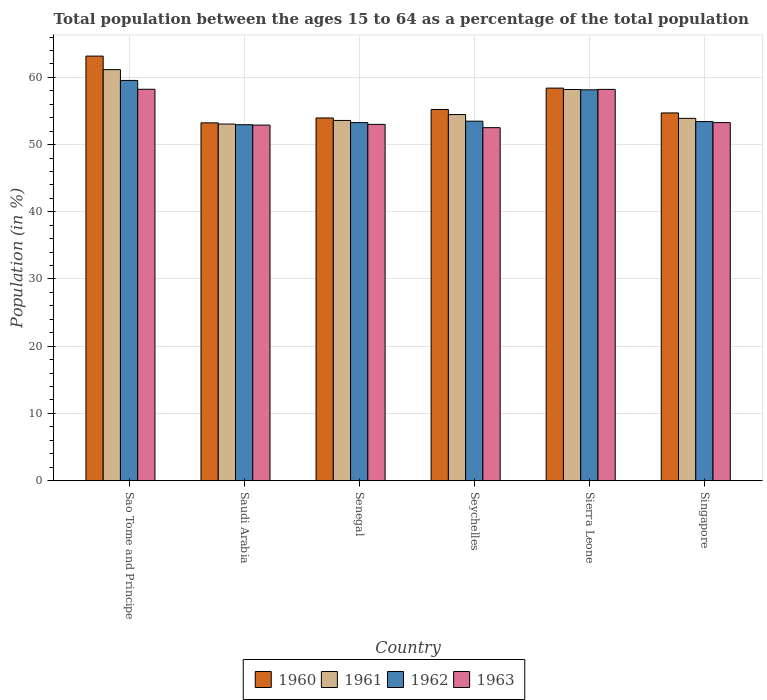How many different coloured bars are there?
Give a very brief answer. 4. Are the number of bars per tick equal to the number of legend labels?
Give a very brief answer. Yes. Are the number of bars on each tick of the X-axis equal?
Your answer should be very brief. Yes. How many bars are there on the 1st tick from the left?
Offer a very short reply. 4. What is the label of the 4th group of bars from the left?
Your response must be concise. Seychelles. What is the percentage of the population ages 15 to 64 in 1961 in Singapore?
Offer a terse response. 53.91. Across all countries, what is the maximum percentage of the population ages 15 to 64 in 1962?
Offer a terse response. 59.54. Across all countries, what is the minimum percentage of the population ages 15 to 64 in 1963?
Give a very brief answer. 52.52. In which country was the percentage of the population ages 15 to 64 in 1962 maximum?
Offer a very short reply. Sao Tome and Principe. In which country was the percentage of the population ages 15 to 64 in 1961 minimum?
Offer a very short reply. Saudi Arabia. What is the total percentage of the population ages 15 to 64 in 1962 in the graph?
Your response must be concise. 330.83. What is the difference between the percentage of the population ages 15 to 64 in 1963 in Saudi Arabia and that in Sierra Leone?
Provide a succinct answer. -5.31. What is the difference between the percentage of the population ages 15 to 64 in 1962 in Singapore and the percentage of the population ages 15 to 64 in 1963 in Seychelles?
Your answer should be very brief. 0.91. What is the average percentage of the population ages 15 to 64 in 1963 per country?
Offer a very short reply. 54.69. What is the difference between the percentage of the population ages 15 to 64 of/in 1962 and percentage of the population ages 15 to 64 of/in 1963 in Singapore?
Give a very brief answer. 0.15. What is the ratio of the percentage of the population ages 15 to 64 in 1962 in Saudi Arabia to that in Seychelles?
Keep it short and to the point. 0.99. Is the difference between the percentage of the population ages 15 to 64 in 1962 in Senegal and Singapore greater than the difference between the percentage of the population ages 15 to 64 in 1963 in Senegal and Singapore?
Your answer should be very brief. Yes. What is the difference between the highest and the second highest percentage of the population ages 15 to 64 in 1960?
Make the answer very short. 3.18. What is the difference between the highest and the lowest percentage of the population ages 15 to 64 in 1962?
Provide a succinct answer. 6.59. In how many countries, is the percentage of the population ages 15 to 64 in 1960 greater than the average percentage of the population ages 15 to 64 in 1960 taken over all countries?
Provide a succinct answer. 2. Is it the case that in every country, the sum of the percentage of the population ages 15 to 64 in 1962 and percentage of the population ages 15 to 64 in 1961 is greater than the sum of percentage of the population ages 15 to 64 in 1960 and percentage of the population ages 15 to 64 in 1963?
Offer a very short reply. No. What does the 1st bar from the left in Senegal represents?
Ensure brevity in your answer.  1960. How many bars are there?
Provide a short and direct response. 24. How many countries are there in the graph?
Offer a terse response. 6. Where does the legend appear in the graph?
Ensure brevity in your answer.  Bottom center. How many legend labels are there?
Offer a very short reply. 4. What is the title of the graph?
Provide a succinct answer. Total population between the ages 15 to 64 as a percentage of the total population. What is the Population (in %) in 1960 in Sao Tome and Principe?
Make the answer very short. 63.17. What is the Population (in %) of 1961 in Sao Tome and Principe?
Keep it short and to the point. 61.16. What is the Population (in %) of 1962 in Sao Tome and Principe?
Make the answer very short. 59.54. What is the Population (in %) of 1963 in Sao Tome and Principe?
Keep it short and to the point. 58.23. What is the Population (in %) in 1960 in Saudi Arabia?
Provide a succinct answer. 53.23. What is the Population (in %) in 1961 in Saudi Arabia?
Offer a very short reply. 53.05. What is the Population (in %) of 1962 in Saudi Arabia?
Provide a succinct answer. 52.96. What is the Population (in %) in 1963 in Saudi Arabia?
Offer a very short reply. 52.9. What is the Population (in %) of 1960 in Senegal?
Offer a very short reply. 53.96. What is the Population (in %) of 1961 in Senegal?
Offer a very short reply. 53.59. What is the Population (in %) of 1962 in Senegal?
Give a very brief answer. 53.27. What is the Population (in %) in 1963 in Senegal?
Your response must be concise. 53.01. What is the Population (in %) of 1960 in Seychelles?
Your response must be concise. 55.23. What is the Population (in %) of 1961 in Seychelles?
Your answer should be compact. 54.47. What is the Population (in %) of 1962 in Seychelles?
Offer a terse response. 53.48. What is the Population (in %) in 1963 in Seychelles?
Keep it short and to the point. 52.52. What is the Population (in %) of 1960 in Sierra Leone?
Provide a succinct answer. 58.4. What is the Population (in %) in 1961 in Sierra Leone?
Offer a terse response. 58.2. What is the Population (in %) of 1962 in Sierra Leone?
Offer a terse response. 58.15. What is the Population (in %) in 1963 in Sierra Leone?
Offer a terse response. 58.21. What is the Population (in %) of 1960 in Singapore?
Give a very brief answer. 54.71. What is the Population (in %) in 1961 in Singapore?
Give a very brief answer. 53.91. What is the Population (in %) of 1962 in Singapore?
Offer a very short reply. 53.42. What is the Population (in %) of 1963 in Singapore?
Offer a terse response. 53.27. Across all countries, what is the maximum Population (in %) of 1960?
Provide a succinct answer. 63.17. Across all countries, what is the maximum Population (in %) of 1961?
Give a very brief answer. 61.16. Across all countries, what is the maximum Population (in %) in 1962?
Offer a terse response. 59.54. Across all countries, what is the maximum Population (in %) in 1963?
Your answer should be compact. 58.23. Across all countries, what is the minimum Population (in %) in 1960?
Keep it short and to the point. 53.23. Across all countries, what is the minimum Population (in %) of 1961?
Offer a very short reply. 53.05. Across all countries, what is the minimum Population (in %) in 1962?
Make the answer very short. 52.96. Across all countries, what is the minimum Population (in %) in 1963?
Your answer should be very brief. 52.52. What is the total Population (in %) in 1960 in the graph?
Ensure brevity in your answer.  338.7. What is the total Population (in %) in 1961 in the graph?
Offer a terse response. 334.37. What is the total Population (in %) of 1962 in the graph?
Your response must be concise. 330.83. What is the total Population (in %) in 1963 in the graph?
Offer a very short reply. 328.15. What is the difference between the Population (in %) of 1960 in Sao Tome and Principe and that in Saudi Arabia?
Your answer should be very brief. 9.94. What is the difference between the Population (in %) in 1961 in Sao Tome and Principe and that in Saudi Arabia?
Offer a very short reply. 8.1. What is the difference between the Population (in %) of 1962 in Sao Tome and Principe and that in Saudi Arabia?
Your answer should be very brief. 6.59. What is the difference between the Population (in %) of 1963 in Sao Tome and Principe and that in Saudi Arabia?
Provide a short and direct response. 5.33. What is the difference between the Population (in %) of 1960 in Sao Tome and Principe and that in Senegal?
Keep it short and to the point. 9.21. What is the difference between the Population (in %) of 1961 in Sao Tome and Principe and that in Senegal?
Ensure brevity in your answer.  7.56. What is the difference between the Population (in %) of 1962 in Sao Tome and Principe and that in Senegal?
Give a very brief answer. 6.27. What is the difference between the Population (in %) of 1963 in Sao Tome and Principe and that in Senegal?
Offer a terse response. 5.22. What is the difference between the Population (in %) of 1960 in Sao Tome and Principe and that in Seychelles?
Keep it short and to the point. 7.94. What is the difference between the Population (in %) in 1961 in Sao Tome and Principe and that in Seychelles?
Offer a very short reply. 6.69. What is the difference between the Population (in %) in 1962 in Sao Tome and Principe and that in Seychelles?
Ensure brevity in your answer.  6.06. What is the difference between the Population (in %) of 1963 in Sao Tome and Principe and that in Seychelles?
Make the answer very short. 5.71. What is the difference between the Population (in %) of 1960 in Sao Tome and Principe and that in Sierra Leone?
Your answer should be compact. 4.77. What is the difference between the Population (in %) of 1961 in Sao Tome and Principe and that in Sierra Leone?
Your answer should be compact. 2.96. What is the difference between the Population (in %) of 1962 in Sao Tome and Principe and that in Sierra Leone?
Your response must be concise. 1.39. What is the difference between the Population (in %) of 1963 in Sao Tome and Principe and that in Sierra Leone?
Provide a short and direct response. 0.02. What is the difference between the Population (in %) of 1960 in Sao Tome and Principe and that in Singapore?
Provide a succinct answer. 8.46. What is the difference between the Population (in %) in 1961 in Sao Tome and Principe and that in Singapore?
Offer a very short reply. 7.25. What is the difference between the Population (in %) of 1962 in Sao Tome and Principe and that in Singapore?
Keep it short and to the point. 6.12. What is the difference between the Population (in %) in 1963 in Sao Tome and Principe and that in Singapore?
Your answer should be very brief. 4.96. What is the difference between the Population (in %) of 1960 in Saudi Arabia and that in Senegal?
Your answer should be compact. -0.73. What is the difference between the Population (in %) of 1961 in Saudi Arabia and that in Senegal?
Offer a terse response. -0.54. What is the difference between the Population (in %) of 1962 in Saudi Arabia and that in Senegal?
Keep it short and to the point. -0.31. What is the difference between the Population (in %) of 1963 in Saudi Arabia and that in Senegal?
Your answer should be compact. -0.11. What is the difference between the Population (in %) in 1960 in Saudi Arabia and that in Seychelles?
Ensure brevity in your answer.  -1.99. What is the difference between the Population (in %) in 1961 in Saudi Arabia and that in Seychelles?
Keep it short and to the point. -1.41. What is the difference between the Population (in %) in 1962 in Saudi Arabia and that in Seychelles?
Your answer should be compact. -0.53. What is the difference between the Population (in %) in 1963 in Saudi Arabia and that in Seychelles?
Make the answer very short. 0.38. What is the difference between the Population (in %) of 1960 in Saudi Arabia and that in Sierra Leone?
Provide a succinct answer. -5.17. What is the difference between the Population (in %) of 1961 in Saudi Arabia and that in Sierra Leone?
Provide a short and direct response. -5.14. What is the difference between the Population (in %) in 1962 in Saudi Arabia and that in Sierra Leone?
Keep it short and to the point. -5.2. What is the difference between the Population (in %) in 1963 in Saudi Arabia and that in Sierra Leone?
Provide a short and direct response. -5.31. What is the difference between the Population (in %) in 1960 in Saudi Arabia and that in Singapore?
Give a very brief answer. -1.48. What is the difference between the Population (in %) of 1961 in Saudi Arabia and that in Singapore?
Give a very brief answer. -0.85. What is the difference between the Population (in %) in 1962 in Saudi Arabia and that in Singapore?
Ensure brevity in your answer.  -0.47. What is the difference between the Population (in %) of 1963 in Saudi Arabia and that in Singapore?
Your answer should be compact. -0.37. What is the difference between the Population (in %) of 1960 in Senegal and that in Seychelles?
Provide a short and direct response. -1.26. What is the difference between the Population (in %) of 1961 in Senegal and that in Seychelles?
Make the answer very short. -0.87. What is the difference between the Population (in %) of 1962 in Senegal and that in Seychelles?
Your answer should be very brief. -0.21. What is the difference between the Population (in %) of 1963 in Senegal and that in Seychelles?
Offer a very short reply. 0.49. What is the difference between the Population (in %) of 1960 in Senegal and that in Sierra Leone?
Offer a terse response. -4.44. What is the difference between the Population (in %) in 1961 in Senegal and that in Sierra Leone?
Your answer should be compact. -4.6. What is the difference between the Population (in %) in 1962 in Senegal and that in Sierra Leone?
Your response must be concise. -4.88. What is the difference between the Population (in %) of 1963 in Senegal and that in Sierra Leone?
Your answer should be compact. -5.21. What is the difference between the Population (in %) of 1960 in Senegal and that in Singapore?
Make the answer very short. -0.75. What is the difference between the Population (in %) of 1961 in Senegal and that in Singapore?
Your response must be concise. -0.31. What is the difference between the Population (in %) in 1962 in Senegal and that in Singapore?
Provide a short and direct response. -0.15. What is the difference between the Population (in %) in 1963 in Senegal and that in Singapore?
Make the answer very short. -0.26. What is the difference between the Population (in %) of 1960 in Seychelles and that in Sierra Leone?
Provide a short and direct response. -3.18. What is the difference between the Population (in %) in 1961 in Seychelles and that in Sierra Leone?
Offer a very short reply. -3.73. What is the difference between the Population (in %) of 1962 in Seychelles and that in Sierra Leone?
Your response must be concise. -4.67. What is the difference between the Population (in %) in 1963 in Seychelles and that in Sierra Leone?
Your answer should be compact. -5.7. What is the difference between the Population (in %) in 1960 in Seychelles and that in Singapore?
Offer a terse response. 0.52. What is the difference between the Population (in %) in 1961 in Seychelles and that in Singapore?
Give a very brief answer. 0.56. What is the difference between the Population (in %) in 1962 in Seychelles and that in Singapore?
Keep it short and to the point. 0.06. What is the difference between the Population (in %) of 1963 in Seychelles and that in Singapore?
Ensure brevity in your answer.  -0.75. What is the difference between the Population (in %) in 1960 in Sierra Leone and that in Singapore?
Your answer should be compact. 3.69. What is the difference between the Population (in %) of 1961 in Sierra Leone and that in Singapore?
Give a very brief answer. 4.29. What is the difference between the Population (in %) in 1962 in Sierra Leone and that in Singapore?
Give a very brief answer. 4.73. What is the difference between the Population (in %) in 1963 in Sierra Leone and that in Singapore?
Keep it short and to the point. 4.94. What is the difference between the Population (in %) of 1960 in Sao Tome and Principe and the Population (in %) of 1961 in Saudi Arabia?
Your response must be concise. 10.11. What is the difference between the Population (in %) in 1960 in Sao Tome and Principe and the Population (in %) in 1962 in Saudi Arabia?
Give a very brief answer. 10.21. What is the difference between the Population (in %) of 1960 in Sao Tome and Principe and the Population (in %) of 1963 in Saudi Arabia?
Your answer should be compact. 10.27. What is the difference between the Population (in %) in 1961 in Sao Tome and Principe and the Population (in %) in 1962 in Saudi Arabia?
Offer a terse response. 8.2. What is the difference between the Population (in %) of 1961 in Sao Tome and Principe and the Population (in %) of 1963 in Saudi Arabia?
Provide a short and direct response. 8.25. What is the difference between the Population (in %) in 1962 in Sao Tome and Principe and the Population (in %) in 1963 in Saudi Arabia?
Your response must be concise. 6.64. What is the difference between the Population (in %) in 1960 in Sao Tome and Principe and the Population (in %) in 1961 in Senegal?
Ensure brevity in your answer.  9.57. What is the difference between the Population (in %) of 1960 in Sao Tome and Principe and the Population (in %) of 1962 in Senegal?
Offer a very short reply. 9.9. What is the difference between the Population (in %) of 1960 in Sao Tome and Principe and the Population (in %) of 1963 in Senegal?
Give a very brief answer. 10.16. What is the difference between the Population (in %) of 1961 in Sao Tome and Principe and the Population (in %) of 1962 in Senegal?
Give a very brief answer. 7.88. What is the difference between the Population (in %) in 1961 in Sao Tome and Principe and the Population (in %) in 1963 in Senegal?
Ensure brevity in your answer.  8.15. What is the difference between the Population (in %) in 1962 in Sao Tome and Principe and the Population (in %) in 1963 in Senegal?
Provide a short and direct response. 6.54. What is the difference between the Population (in %) in 1960 in Sao Tome and Principe and the Population (in %) in 1961 in Seychelles?
Your answer should be very brief. 8.7. What is the difference between the Population (in %) in 1960 in Sao Tome and Principe and the Population (in %) in 1962 in Seychelles?
Make the answer very short. 9.68. What is the difference between the Population (in %) of 1960 in Sao Tome and Principe and the Population (in %) of 1963 in Seychelles?
Give a very brief answer. 10.65. What is the difference between the Population (in %) of 1961 in Sao Tome and Principe and the Population (in %) of 1962 in Seychelles?
Your response must be concise. 7.67. What is the difference between the Population (in %) in 1961 in Sao Tome and Principe and the Population (in %) in 1963 in Seychelles?
Make the answer very short. 8.64. What is the difference between the Population (in %) in 1962 in Sao Tome and Principe and the Population (in %) in 1963 in Seychelles?
Make the answer very short. 7.03. What is the difference between the Population (in %) of 1960 in Sao Tome and Principe and the Population (in %) of 1961 in Sierra Leone?
Provide a short and direct response. 4.97. What is the difference between the Population (in %) in 1960 in Sao Tome and Principe and the Population (in %) in 1962 in Sierra Leone?
Keep it short and to the point. 5.02. What is the difference between the Population (in %) of 1960 in Sao Tome and Principe and the Population (in %) of 1963 in Sierra Leone?
Offer a terse response. 4.95. What is the difference between the Population (in %) of 1961 in Sao Tome and Principe and the Population (in %) of 1962 in Sierra Leone?
Provide a succinct answer. 3. What is the difference between the Population (in %) in 1961 in Sao Tome and Principe and the Population (in %) in 1963 in Sierra Leone?
Make the answer very short. 2.94. What is the difference between the Population (in %) in 1962 in Sao Tome and Principe and the Population (in %) in 1963 in Sierra Leone?
Make the answer very short. 1.33. What is the difference between the Population (in %) in 1960 in Sao Tome and Principe and the Population (in %) in 1961 in Singapore?
Your answer should be very brief. 9.26. What is the difference between the Population (in %) in 1960 in Sao Tome and Principe and the Population (in %) in 1962 in Singapore?
Offer a very short reply. 9.74. What is the difference between the Population (in %) of 1960 in Sao Tome and Principe and the Population (in %) of 1963 in Singapore?
Provide a short and direct response. 9.9. What is the difference between the Population (in %) in 1961 in Sao Tome and Principe and the Population (in %) in 1962 in Singapore?
Offer a terse response. 7.73. What is the difference between the Population (in %) in 1961 in Sao Tome and Principe and the Population (in %) in 1963 in Singapore?
Offer a very short reply. 7.88. What is the difference between the Population (in %) of 1962 in Sao Tome and Principe and the Population (in %) of 1963 in Singapore?
Your response must be concise. 6.27. What is the difference between the Population (in %) of 1960 in Saudi Arabia and the Population (in %) of 1961 in Senegal?
Provide a succinct answer. -0.36. What is the difference between the Population (in %) in 1960 in Saudi Arabia and the Population (in %) in 1962 in Senegal?
Give a very brief answer. -0.04. What is the difference between the Population (in %) of 1960 in Saudi Arabia and the Population (in %) of 1963 in Senegal?
Make the answer very short. 0.23. What is the difference between the Population (in %) of 1961 in Saudi Arabia and the Population (in %) of 1962 in Senegal?
Ensure brevity in your answer.  -0.22. What is the difference between the Population (in %) in 1961 in Saudi Arabia and the Population (in %) in 1963 in Senegal?
Your answer should be compact. 0.05. What is the difference between the Population (in %) in 1962 in Saudi Arabia and the Population (in %) in 1963 in Senegal?
Give a very brief answer. -0.05. What is the difference between the Population (in %) of 1960 in Saudi Arabia and the Population (in %) of 1961 in Seychelles?
Your response must be concise. -1.23. What is the difference between the Population (in %) in 1960 in Saudi Arabia and the Population (in %) in 1962 in Seychelles?
Offer a very short reply. -0.25. What is the difference between the Population (in %) of 1960 in Saudi Arabia and the Population (in %) of 1963 in Seychelles?
Offer a very short reply. 0.71. What is the difference between the Population (in %) in 1961 in Saudi Arabia and the Population (in %) in 1962 in Seychelles?
Offer a very short reply. -0.43. What is the difference between the Population (in %) in 1961 in Saudi Arabia and the Population (in %) in 1963 in Seychelles?
Provide a short and direct response. 0.54. What is the difference between the Population (in %) of 1962 in Saudi Arabia and the Population (in %) of 1963 in Seychelles?
Your answer should be very brief. 0.44. What is the difference between the Population (in %) of 1960 in Saudi Arabia and the Population (in %) of 1961 in Sierra Leone?
Give a very brief answer. -4.96. What is the difference between the Population (in %) of 1960 in Saudi Arabia and the Population (in %) of 1962 in Sierra Leone?
Provide a succinct answer. -4.92. What is the difference between the Population (in %) of 1960 in Saudi Arabia and the Population (in %) of 1963 in Sierra Leone?
Provide a short and direct response. -4.98. What is the difference between the Population (in %) in 1961 in Saudi Arabia and the Population (in %) in 1962 in Sierra Leone?
Offer a terse response. -5.1. What is the difference between the Population (in %) of 1961 in Saudi Arabia and the Population (in %) of 1963 in Sierra Leone?
Ensure brevity in your answer.  -5.16. What is the difference between the Population (in %) of 1962 in Saudi Arabia and the Population (in %) of 1963 in Sierra Leone?
Provide a short and direct response. -5.26. What is the difference between the Population (in %) in 1960 in Saudi Arabia and the Population (in %) in 1961 in Singapore?
Keep it short and to the point. -0.67. What is the difference between the Population (in %) of 1960 in Saudi Arabia and the Population (in %) of 1962 in Singapore?
Provide a short and direct response. -0.19. What is the difference between the Population (in %) in 1960 in Saudi Arabia and the Population (in %) in 1963 in Singapore?
Your answer should be very brief. -0.04. What is the difference between the Population (in %) of 1961 in Saudi Arabia and the Population (in %) of 1962 in Singapore?
Ensure brevity in your answer.  -0.37. What is the difference between the Population (in %) of 1961 in Saudi Arabia and the Population (in %) of 1963 in Singapore?
Offer a terse response. -0.22. What is the difference between the Population (in %) of 1962 in Saudi Arabia and the Population (in %) of 1963 in Singapore?
Offer a terse response. -0.31. What is the difference between the Population (in %) of 1960 in Senegal and the Population (in %) of 1961 in Seychelles?
Provide a short and direct response. -0.51. What is the difference between the Population (in %) of 1960 in Senegal and the Population (in %) of 1962 in Seychelles?
Ensure brevity in your answer.  0.48. What is the difference between the Population (in %) of 1960 in Senegal and the Population (in %) of 1963 in Seychelles?
Your answer should be compact. 1.44. What is the difference between the Population (in %) of 1961 in Senegal and the Population (in %) of 1962 in Seychelles?
Make the answer very short. 0.11. What is the difference between the Population (in %) of 1961 in Senegal and the Population (in %) of 1963 in Seychelles?
Your response must be concise. 1.07. What is the difference between the Population (in %) of 1962 in Senegal and the Population (in %) of 1963 in Seychelles?
Offer a terse response. 0.75. What is the difference between the Population (in %) in 1960 in Senegal and the Population (in %) in 1961 in Sierra Leone?
Your answer should be compact. -4.24. What is the difference between the Population (in %) in 1960 in Senegal and the Population (in %) in 1962 in Sierra Leone?
Offer a terse response. -4.19. What is the difference between the Population (in %) in 1960 in Senegal and the Population (in %) in 1963 in Sierra Leone?
Your response must be concise. -4.25. What is the difference between the Population (in %) of 1961 in Senegal and the Population (in %) of 1962 in Sierra Leone?
Offer a very short reply. -4.56. What is the difference between the Population (in %) in 1961 in Senegal and the Population (in %) in 1963 in Sierra Leone?
Ensure brevity in your answer.  -4.62. What is the difference between the Population (in %) in 1962 in Senegal and the Population (in %) in 1963 in Sierra Leone?
Your response must be concise. -4.94. What is the difference between the Population (in %) of 1960 in Senegal and the Population (in %) of 1961 in Singapore?
Provide a short and direct response. 0.06. What is the difference between the Population (in %) of 1960 in Senegal and the Population (in %) of 1962 in Singapore?
Provide a short and direct response. 0.54. What is the difference between the Population (in %) in 1960 in Senegal and the Population (in %) in 1963 in Singapore?
Give a very brief answer. 0.69. What is the difference between the Population (in %) in 1961 in Senegal and the Population (in %) in 1962 in Singapore?
Provide a short and direct response. 0.17. What is the difference between the Population (in %) in 1961 in Senegal and the Population (in %) in 1963 in Singapore?
Provide a succinct answer. 0.32. What is the difference between the Population (in %) of 1962 in Senegal and the Population (in %) of 1963 in Singapore?
Make the answer very short. -0. What is the difference between the Population (in %) in 1960 in Seychelles and the Population (in %) in 1961 in Sierra Leone?
Your response must be concise. -2.97. What is the difference between the Population (in %) in 1960 in Seychelles and the Population (in %) in 1962 in Sierra Leone?
Make the answer very short. -2.93. What is the difference between the Population (in %) of 1960 in Seychelles and the Population (in %) of 1963 in Sierra Leone?
Make the answer very short. -2.99. What is the difference between the Population (in %) in 1961 in Seychelles and the Population (in %) in 1962 in Sierra Leone?
Keep it short and to the point. -3.69. What is the difference between the Population (in %) of 1961 in Seychelles and the Population (in %) of 1963 in Sierra Leone?
Ensure brevity in your answer.  -3.75. What is the difference between the Population (in %) in 1962 in Seychelles and the Population (in %) in 1963 in Sierra Leone?
Provide a succinct answer. -4.73. What is the difference between the Population (in %) of 1960 in Seychelles and the Population (in %) of 1961 in Singapore?
Offer a terse response. 1.32. What is the difference between the Population (in %) in 1960 in Seychelles and the Population (in %) in 1962 in Singapore?
Give a very brief answer. 1.8. What is the difference between the Population (in %) in 1960 in Seychelles and the Population (in %) in 1963 in Singapore?
Offer a very short reply. 1.96. What is the difference between the Population (in %) of 1961 in Seychelles and the Population (in %) of 1962 in Singapore?
Provide a succinct answer. 1.04. What is the difference between the Population (in %) of 1961 in Seychelles and the Population (in %) of 1963 in Singapore?
Your answer should be very brief. 1.2. What is the difference between the Population (in %) of 1962 in Seychelles and the Population (in %) of 1963 in Singapore?
Provide a short and direct response. 0.21. What is the difference between the Population (in %) in 1960 in Sierra Leone and the Population (in %) in 1961 in Singapore?
Your response must be concise. 4.5. What is the difference between the Population (in %) in 1960 in Sierra Leone and the Population (in %) in 1962 in Singapore?
Keep it short and to the point. 4.98. What is the difference between the Population (in %) in 1960 in Sierra Leone and the Population (in %) in 1963 in Singapore?
Make the answer very short. 5.13. What is the difference between the Population (in %) of 1961 in Sierra Leone and the Population (in %) of 1962 in Singapore?
Your response must be concise. 4.77. What is the difference between the Population (in %) of 1961 in Sierra Leone and the Population (in %) of 1963 in Singapore?
Your answer should be very brief. 4.93. What is the difference between the Population (in %) of 1962 in Sierra Leone and the Population (in %) of 1963 in Singapore?
Offer a terse response. 4.88. What is the average Population (in %) in 1960 per country?
Offer a terse response. 56.45. What is the average Population (in %) of 1961 per country?
Offer a very short reply. 55.73. What is the average Population (in %) of 1962 per country?
Ensure brevity in your answer.  55.14. What is the average Population (in %) in 1963 per country?
Your answer should be very brief. 54.69. What is the difference between the Population (in %) of 1960 and Population (in %) of 1961 in Sao Tome and Principe?
Provide a succinct answer. 2.01. What is the difference between the Population (in %) of 1960 and Population (in %) of 1962 in Sao Tome and Principe?
Give a very brief answer. 3.62. What is the difference between the Population (in %) of 1960 and Population (in %) of 1963 in Sao Tome and Principe?
Offer a very short reply. 4.94. What is the difference between the Population (in %) in 1961 and Population (in %) in 1962 in Sao Tome and Principe?
Your response must be concise. 1.61. What is the difference between the Population (in %) of 1961 and Population (in %) of 1963 in Sao Tome and Principe?
Keep it short and to the point. 2.92. What is the difference between the Population (in %) in 1962 and Population (in %) in 1963 in Sao Tome and Principe?
Provide a short and direct response. 1.31. What is the difference between the Population (in %) of 1960 and Population (in %) of 1961 in Saudi Arabia?
Ensure brevity in your answer.  0.18. What is the difference between the Population (in %) of 1960 and Population (in %) of 1962 in Saudi Arabia?
Make the answer very short. 0.28. What is the difference between the Population (in %) in 1960 and Population (in %) in 1963 in Saudi Arabia?
Provide a succinct answer. 0.33. What is the difference between the Population (in %) of 1961 and Population (in %) of 1962 in Saudi Arabia?
Make the answer very short. 0.1. What is the difference between the Population (in %) of 1961 and Population (in %) of 1963 in Saudi Arabia?
Give a very brief answer. 0.15. What is the difference between the Population (in %) in 1962 and Population (in %) in 1963 in Saudi Arabia?
Offer a terse response. 0.06. What is the difference between the Population (in %) of 1960 and Population (in %) of 1961 in Senegal?
Keep it short and to the point. 0.37. What is the difference between the Population (in %) in 1960 and Population (in %) in 1962 in Senegal?
Make the answer very short. 0.69. What is the difference between the Population (in %) in 1960 and Population (in %) in 1963 in Senegal?
Give a very brief answer. 0.95. What is the difference between the Population (in %) of 1961 and Population (in %) of 1962 in Senegal?
Make the answer very short. 0.32. What is the difference between the Population (in %) in 1961 and Population (in %) in 1963 in Senegal?
Ensure brevity in your answer.  0.59. What is the difference between the Population (in %) of 1962 and Population (in %) of 1963 in Senegal?
Offer a very short reply. 0.26. What is the difference between the Population (in %) in 1960 and Population (in %) in 1961 in Seychelles?
Offer a terse response. 0.76. What is the difference between the Population (in %) of 1960 and Population (in %) of 1962 in Seychelles?
Your answer should be compact. 1.74. What is the difference between the Population (in %) of 1960 and Population (in %) of 1963 in Seychelles?
Make the answer very short. 2.71. What is the difference between the Population (in %) of 1961 and Population (in %) of 1962 in Seychelles?
Your answer should be compact. 0.98. What is the difference between the Population (in %) in 1961 and Population (in %) in 1963 in Seychelles?
Make the answer very short. 1.95. What is the difference between the Population (in %) of 1962 and Population (in %) of 1963 in Seychelles?
Provide a short and direct response. 0.96. What is the difference between the Population (in %) in 1960 and Population (in %) in 1961 in Sierra Leone?
Your response must be concise. 0.21. What is the difference between the Population (in %) of 1960 and Population (in %) of 1962 in Sierra Leone?
Ensure brevity in your answer.  0.25. What is the difference between the Population (in %) of 1960 and Population (in %) of 1963 in Sierra Leone?
Your response must be concise. 0.19. What is the difference between the Population (in %) of 1961 and Population (in %) of 1962 in Sierra Leone?
Your answer should be compact. 0.05. What is the difference between the Population (in %) in 1961 and Population (in %) in 1963 in Sierra Leone?
Provide a short and direct response. -0.02. What is the difference between the Population (in %) of 1962 and Population (in %) of 1963 in Sierra Leone?
Keep it short and to the point. -0.06. What is the difference between the Population (in %) in 1960 and Population (in %) in 1961 in Singapore?
Provide a succinct answer. 0.81. What is the difference between the Population (in %) in 1960 and Population (in %) in 1962 in Singapore?
Your answer should be compact. 1.29. What is the difference between the Population (in %) of 1960 and Population (in %) of 1963 in Singapore?
Ensure brevity in your answer.  1.44. What is the difference between the Population (in %) of 1961 and Population (in %) of 1962 in Singapore?
Your answer should be very brief. 0.48. What is the difference between the Population (in %) in 1961 and Population (in %) in 1963 in Singapore?
Your answer should be compact. 0.63. What is the difference between the Population (in %) of 1962 and Population (in %) of 1963 in Singapore?
Provide a short and direct response. 0.15. What is the ratio of the Population (in %) in 1960 in Sao Tome and Principe to that in Saudi Arabia?
Your answer should be compact. 1.19. What is the ratio of the Population (in %) in 1961 in Sao Tome and Principe to that in Saudi Arabia?
Provide a succinct answer. 1.15. What is the ratio of the Population (in %) of 1962 in Sao Tome and Principe to that in Saudi Arabia?
Offer a terse response. 1.12. What is the ratio of the Population (in %) of 1963 in Sao Tome and Principe to that in Saudi Arabia?
Your answer should be very brief. 1.1. What is the ratio of the Population (in %) of 1960 in Sao Tome and Principe to that in Senegal?
Your answer should be compact. 1.17. What is the ratio of the Population (in %) of 1961 in Sao Tome and Principe to that in Senegal?
Your answer should be compact. 1.14. What is the ratio of the Population (in %) in 1962 in Sao Tome and Principe to that in Senegal?
Make the answer very short. 1.12. What is the ratio of the Population (in %) of 1963 in Sao Tome and Principe to that in Senegal?
Provide a short and direct response. 1.1. What is the ratio of the Population (in %) of 1960 in Sao Tome and Principe to that in Seychelles?
Your answer should be very brief. 1.14. What is the ratio of the Population (in %) in 1961 in Sao Tome and Principe to that in Seychelles?
Offer a terse response. 1.12. What is the ratio of the Population (in %) of 1962 in Sao Tome and Principe to that in Seychelles?
Your response must be concise. 1.11. What is the ratio of the Population (in %) of 1963 in Sao Tome and Principe to that in Seychelles?
Your response must be concise. 1.11. What is the ratio of the Population (in %) of 1960 in Sao Tome and Principe to that in Sierra Leone?
Make the answer very short. 1.08. What is the ratio of the Population (in %) in 1961 in Sao Tome and Principe to that in Sierra Leone?
Your response must be concise. 1.05. What is the ratio of the Population (in %) in 1963 in Sao Tome and Principe to that in Sierra Leone?
Ensure brevity in your answer.  1. What is the ratio of the Population (in %) of 1960 in Sao Tome and Principe to that in Singapore?
Provide a succinct answer. 1.15. What is the ratio of the Population (in %) of 1961 in Sao Tome and Principe to that in Singapore?
Give a very brief answer. 1.13. What is the ratio of the Population (in %) of 1962 in Sao Tome and Principe to that in Singapore?
Keep it short and to the point. 1.11. What is the ratio of the Population (in %) of 1963 in Sao Tome and Principe to that in Singapore?
Give a very brief answer. 1.09. What is the ratio of the Population (in %) of 1960 in Saudi Arabia to that in Senegal?
Your answer should be very brief. 0.99. What is the ratio of the Population (in %) in 1963 in Saudi Arabia to that in Senegal?
Your answer should be very brief. 1. What is the ratio of the Population (in %) in 1960 in Saudi Arabia to that in Seychelles?
Ensure brevity in your answer.  0.96. What is the ratio of the Population (in %) of 1961 in Saudi Arabia to that in Seychelles?
Give a very brief answer. 0.97. What is the ratio of the Population (in %) of 1962 in Saudi Arabia to that in Seychelles?
Your answer should be very brief. 0.99. What is the ratio of the Population (in %) of 1963 in Saudi Arabia to that in Seychelles?
Offer a very short reply. 1.01. What is the ratio of the Population (in %) in 1960 in Saudi Arabia to that in Sierra Leone?
Give a very brief answer. 0.91. What is the ratio of the Population (in %) of 1961 in Saudi Arabia to that in Sierra Leone?
Your answer should be very brief. 0.91. What is the ratio of the Population (in %) of 1962 in Saudi Arabia to that in Sierra Leone?
Provide a succinct answer. 0.91. What is the ratio of the Population (in %) of 1963 in Saudi Arabia to that in Sierra Leone?
Offer a very short reply. 0.91. What is the ratio of the Population (in %) of 1961 in Saudi Arabia to that in Singapore?
Offer a very short reply. 0.98. What is the ratio of the Population (in %) in 1962 in Saudi Arabia to that in Singapore?
Your answer should be very brief. 0.99. What is the ratio of the Population (in %) of 1963 in Saudi Arabia to that in Singapore?
Provide a short and direct response. 0.99. What is the ratio of the Population (in %) in 1960 in Senegal to that in Seychelles?
Give a very brief answer. 0.98. What is the ratio of the Population (in %) in 1961 in Senegal to that in Seychelles?
Give a very brief answer. 0.98. What is the ratio of the Population (in %) of 1962 in Senegal to that in Seychelles?
Your answer should be very brief. 1. What is the ratio of the Population (in %) in 1963 in Senegal to that in Seychelles?
Ensure brevity in your answer.  1.01. What is the ratio of the Population (in %) in 1960 in Senegal to that in Sierra Leone?
Make the answer very short. 0.92. What is the ratio of the Population (in %) in 1961 in Senegal to that in Sierra Leone?
Keep it short and to the point. 0.92. What is the ratio of the Population (in %) in 1962 in Senegal to that in Sierra Leone?
Provide a succinct answer. 0.92. What is the ratio of the Population (in %) of 1963 in Senegal to that in Sierra Leone?
Provide a short and direct response. 0.91. What is the ratio of the Population (in %) of 1960 in Senegal to that in Singapore?
Your response must be concise. 0.99. What is the ratio of the Population (in %) in 1963 in Senegal to that in Singapore?
Give a very brief answer. 1. What is the ratio of the Population (in %) of 1960 in Seychelles to that in Sierra Leone?
Keep it short and to the point. 0.95. What is the ratio of the Population (in %) of 1961 in Seychelles to that in Sierra Leone?
Your answer should be very brief. 0.94. What is the ratio of the Population (in %) in 1962 in Seychelles to that in Sierra Leone?
Offer a terse response. 0.92. What is the ratio of the Population (in %) of 1963 in Seychelles to that in Sierra Leone?
Provide a succinct answer. 0.9. What is the ratio of the Population (in %) in 1960 in Seychelles to that in Singapore?
Your answer should be very brief. 1.01. What is the ratio of the Population (in %) of 1961 in Seychelles to that in Singapore?
Your response must be concise. 1.01. What is the ratio of the Population (in %) of 1963 in Seychelles to that in Singapore?
Give a very brief answer. 0.99. What is the ratio of the Population (in %) of 1960 in Sierra Leone to that in Singapore?
Provide a succinct answer. 1.07. What is the ratio of the Population (in %) in 1961 in Sierra Leone to that in Singapore?
Offer a terse response. 1.08. What is the ratio of the Population (in %) in 1962 in Sierra Leone to that in Singapore?
Provide a short and direct response. 1.09. What is the ratio of the Population (in %) in 1963 in Sierra Leone to that in Singapore?
Ensure brevity in your answer.  1.09. What is the difference between the highest and the second highest Population (in %) of 1960?
Provide a succinct answer. 4.77. What is the difference between the highest and the second highest Population (in %) of 1961?
Keep it short and to the point. 2.96. What is the difference between the highest and the second highest Population (in %) of 1962?
Your answer should be compact. 1.39. What is the difference between the highest and the second highest Population (in %) of 1963?
Keep it short and to the point. 0.02. What is the difference between the highest and the lowest Population (in %) in 1960?
Your answer should be compact. 9.94. What is the difference between the highest and the lowest Population (in %) of 1961?
Your answer should be very brief. 8.1. What is the difference between the highest and the lowest Population (in %) in 1962?
Your answer should be very brief. 6.59. What is the difference between the highest and the lowest Population (in %) in 1963?
Offer a very short reply. 5.71. 